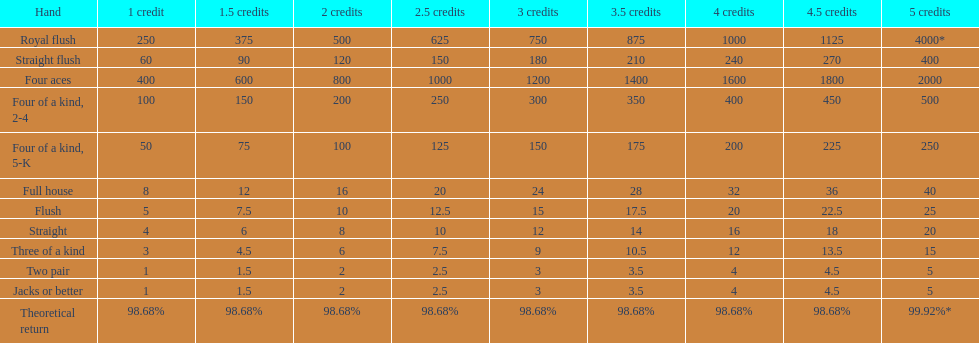Help me parse the entirety of this table. {'header': ['Hand', '1 credit', '1.5 credits', '2 credits', '2.5 credits', '3 credits', '3.5 credits', '4 credits', '4.5 credits', '5 credits'], 'rows': [['Royal flush', '250', '375', '500', '625', '750', '875', '1000', '1125', '4000*'], ['Straight flush', '60', '90', '120', '150', '180', '210', '240', '270', '400'], ['Four aces', '400', '600', '800', '1000', '1200', '1400', '1600', '1800', '2000'], ['Four of a kind, 2-4', '100', '150', '200', '250', '300', '350', '400', '450', '500'], ['Four of a kind, 5-K', '50', '75', '100', '125', '150', '175', '200', '225', '250'], ['Full house', '8', '12', '16', '20', '24', '28', '32', '36', '40'], ['Flush', '5', '7.5', '10', '12.5', '15', '17.5', '20', '22.5', '25'], ['Straight', '4', '6', '8', '10', '12', '14', '16', '18', '20'], ['Three of a kind', '3', '4.5', '6', '7.5', '9', '10.5', '12', '13.5', '15'], ['Two pair', '1', '1.5', '2', '2.5', '3', '3.5', '4', '4.5', '5'], ['Jacks or better', '1', '1.5', '2', '2.5', '3', '3.5', '4', '4.5', '5'], ['Theoretical return', '98.68%', '98.68%', '98.68%', '98.68%', '98.68%', '98.68%', '98.68%', '98.68%', '99.92%*']]} Each four aces win is a multiple of what number? 400. 